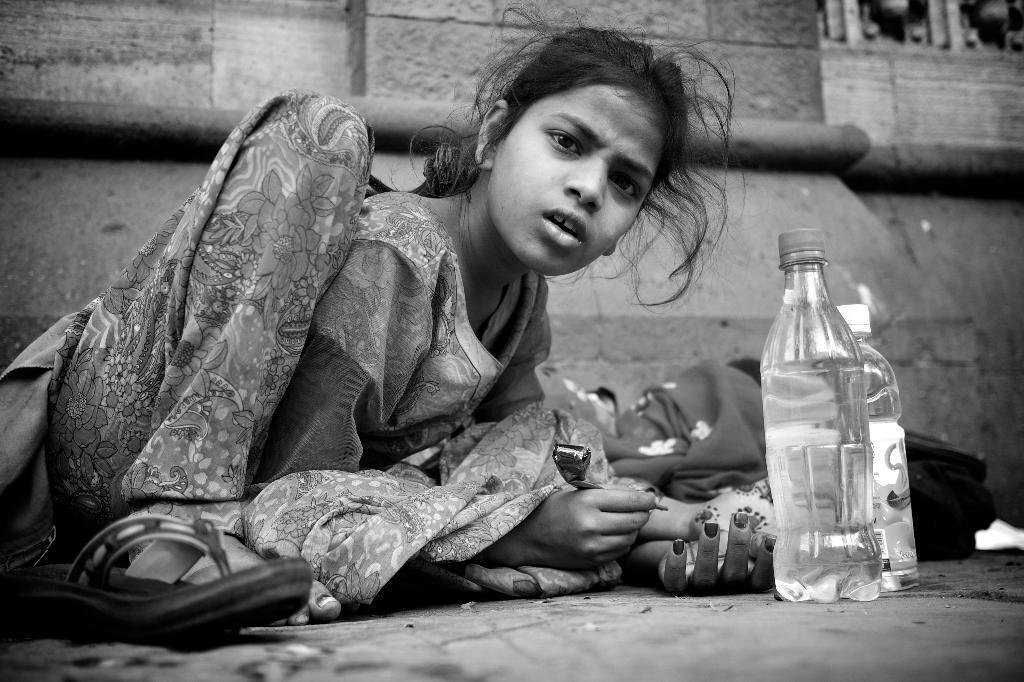Describe this image in one or two sentences. She is sitting on a floor. She is holding a mehndi tube. She is look at a side. There were bottles in front of her. 